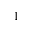<formula> <loc_0><loc_0><loc_500><loc_500>1</formula> 